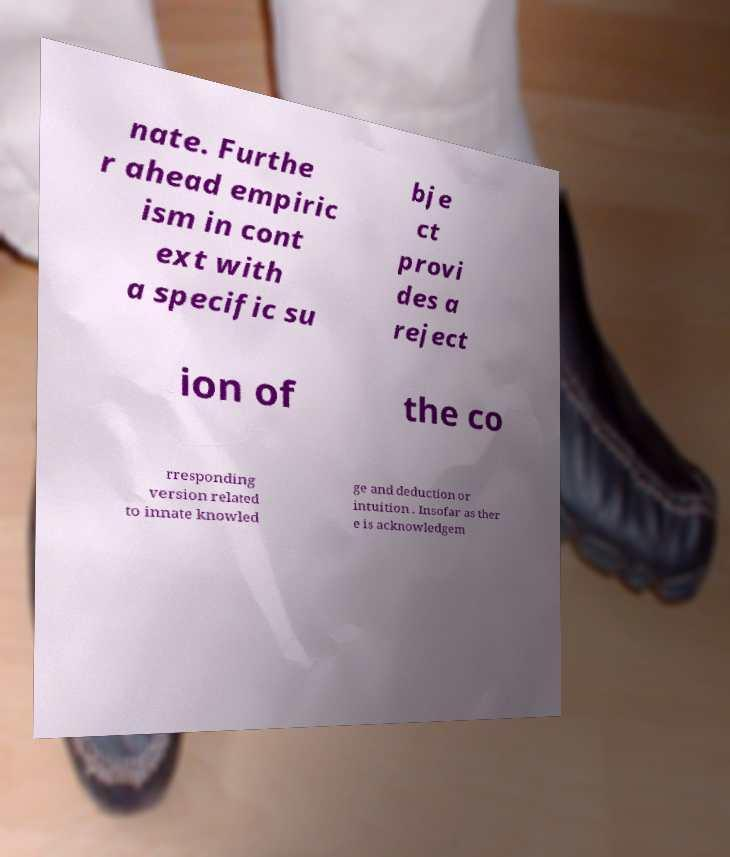Please read and relay the text visible in this image. What does it say? nate. Furthe r ahead empiric ism in cont ext with a specific su bje ct provi des a reject ion of the co rresponding version related to innate knowled ge and deduction or intuition . Insofar as ther e is acknowledgem 